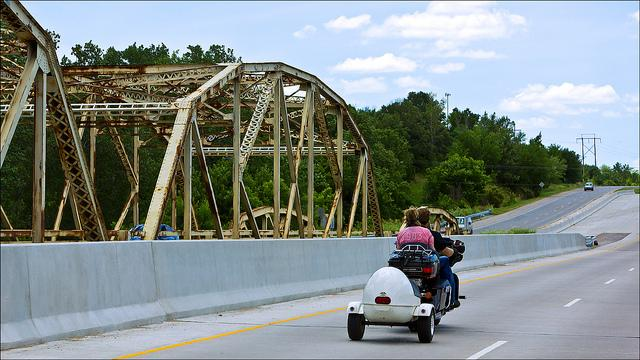What is next to the vehicle? Please explain your reasoning. bridge. The bike is on a bridge. 